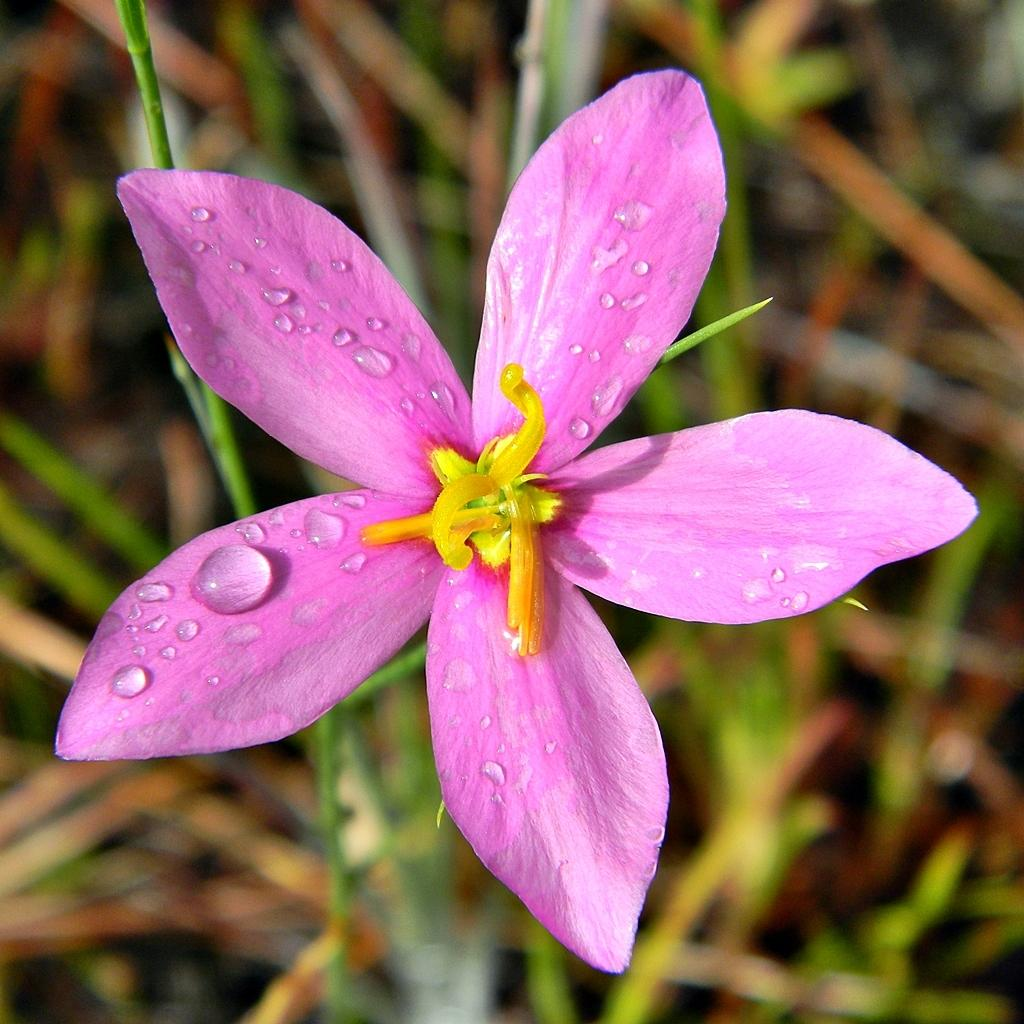What type of flower is present in the image? There is a pink color flower in the image. Can you describe the background of the image? The background of the image is blurred. What type of store can be seen in the background of the image? There is no store present in the image; it only features a pink color flower with a blurred background. What scent can be smelled coming from the flower in the image? The image is a visual representation and does not convey scent information, so it is not possible to determine the scent of the flower from the image. 